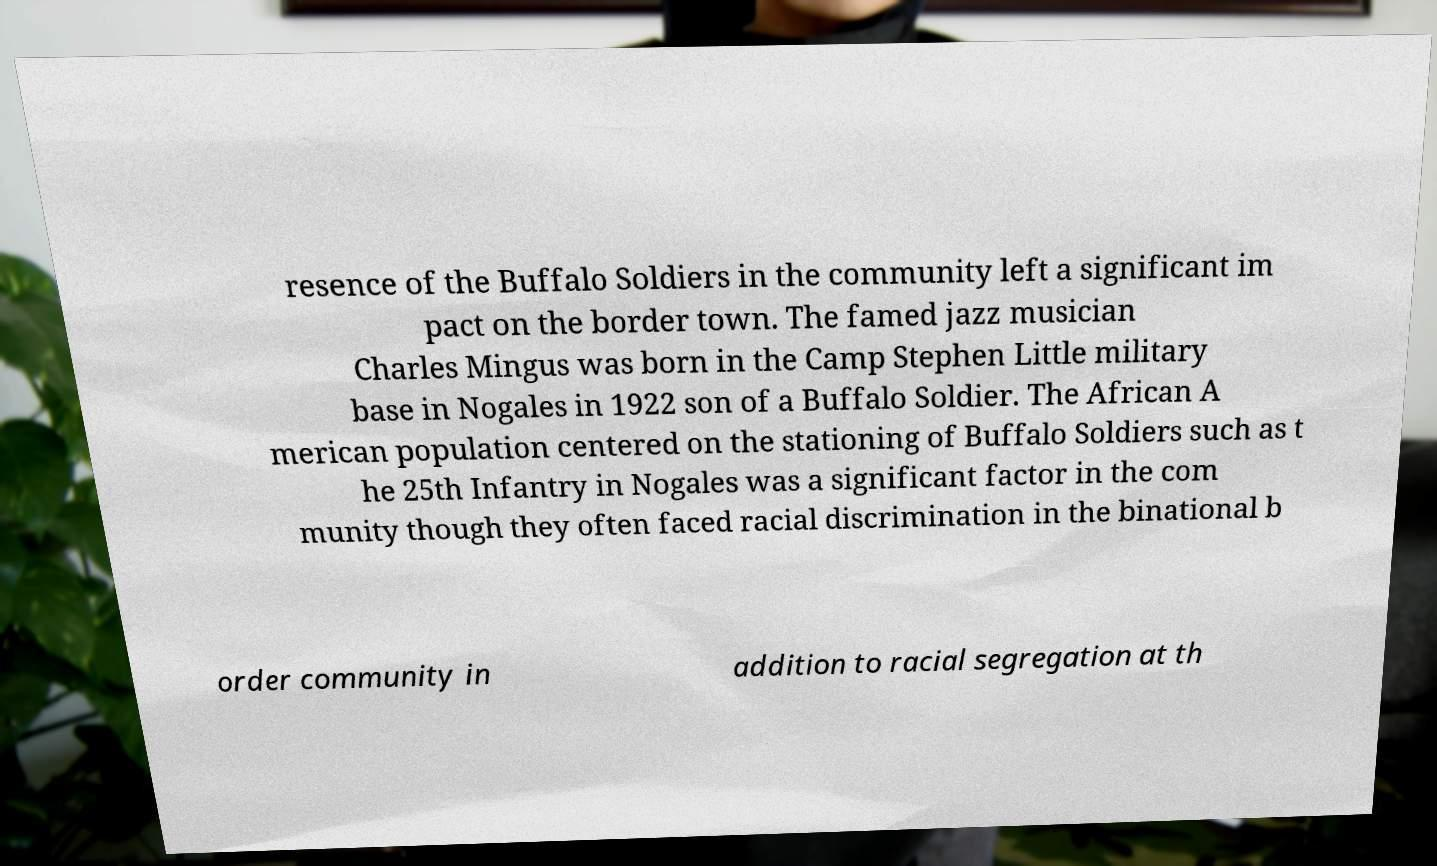Can you accurately transcribe the text from the provided image for me? resence of the Buffalo Soldiers in the community left a significant im pact on the border town. The famed jazz musician Charles Mingus was born in the Camp Stephen Little military base in Nogales in 1922 son of a Buffalo Soldier. The African A merican population centered on the stationing of Buffalo Soldiers such as t he 25th Infantry in Nogales was a significant factor in the com munity though they often faced racial discrimination in the binational b order community in addition to racial segregation at th 